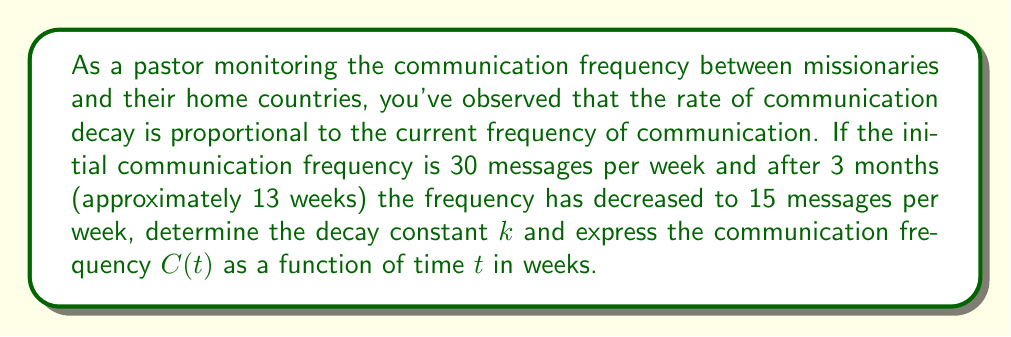Solve this math problem. Let's approach this step-by-step using the principles of exponential decay:

1) The differential equation describing this situation is:
   
   $$\frac{dC}{dt} = -kC$$

   where $C$ is the communication frequency and $k$ is the decay constant.

2) The solution to this differential equation is:
   
   $$C(t) = C_0e^{-kt}$$

   where $C_0$ is the initial communication frequency.

3) We're given that:
   - $C_0 = 30$ messages/week
   - At $t = 13$ weeks, $C = 15$ messages/week

4) Let's substitute these values into our equation:

   $$15 = 30e^{-k(13)}$$

5) Dividing both sides by 30:

   $$\frac{1}{2} = e^{-13k}$$

6) Taking the natural log of both sides:

   $$\ln(\frac{1}{2}) = -13k$$

7) Solving for $k$:

   $$k = -\frac{\ln(\frac{1}{2})}{13} \approx 0.0533$$

8) Now that we have $k$, we can write the full equation for $C(t)$:

   $$C(t) = 30e^{-0.0533t}$$

   where $t$ is measured in weeks.
Answer: The decay constant $k \approx 0.0533$ per week, and the communication frequency as a function of time is $C(t) = 30e^{-0.0533t}$ messages per week, where $t$ is measured in weeks. 